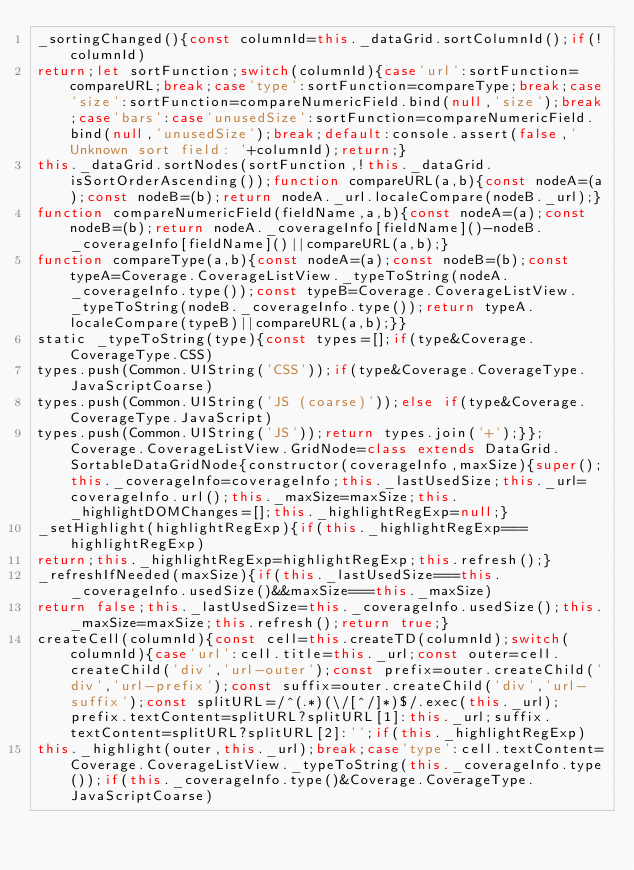<code> <loc_0><loc_0><loc_500><loc_500><_JavaScript_>_sortingChanged(){const columnId=this._dataGrid.sortColumnId();if(!columnId)
return;let sortFunction;switch(columnId){case'url':sortFunction=compareURL;break;case'type':sortFunction=compareType;break;case'size':sortFunction=compareNumericField.bind(null,'size');break;case'bars':case'unusedSize':sortFunction=compareNumericField.bind(null,'unusedSize');break;default:console.assert(false,'Unknown sort field: '+columnId);return;}
this._dataGrid.sortNodes(sortFunction,!this._dataGrid.isSortOrderAscending());function compareURL(a,b){const nodeA=(a);const nodeB=(b);return nodeA._url.localeCompare(nodeB._url);}
function compareNumericField(fieldName,a,b){const nodeA=(a);const nodeB=(b);return nodeA._coverageInfo[fieldName]()-nodeB._coverageInfo[fieldName]()||compareURL(a,b);}
function compareType(a,b){const nodeA=(a);const nodeB=(b);const typeA=Coverage.CoverageListView._typeToString(nodeA._coverageInfo.type());const typeB=Coverage.CoverageListView._typeToString(nodeB._coverageInfo.type());return typeA.localeCompare(typeB)||compareURL(a,b);}}
static _typeToString(type){const types=[];if(type&Coverage.CoverageType.CSS)
types.push(Common.UIString('CSS'));if(type&Coverage.CoverageType.JavaScriptCoarse)
types.push(Common.UIString('JS (coarse)'));else if(type&Coverage.CoverageType.JavaScript)
types.push(Common.UIString('JS'));return types.join('+');}};Coverage.CoverageListView.GridNode=class extends DataGrid.SortableDataGridNode{constructor(coverageInfo,maxSize){super();this._coverageInfo=coverageInfo;this._lastUsedSize;this._url=coverageInfo.url();this._maxSize=maxSize;this._highlightDOMChanges=[];this._highlightRegExp=null;}
_setHighlight(highlightRegExp){if(this._highlightRegExp===highlightRegExp)
return;this._highlightRegExp=highlightRegExp;this.refresh();}
_refreshIfNeeded(maxSize){if(this._lastUsedSize===this._coverageInfo.usedSize()&&maxSize===this._maxSize)
return false;this._lastUsedSize=this._coverageInfo.usedSize();this._maxSize=maxSize;this.refresh();return true;}
createCell(columnId){const cell=this.createTD(columnId);switch(columnId){case'url':cell.title=this._url;const outer=cell.createChild('div','url-outer');const prefix=outer.createChild('div','url-prefix');const suffix=outer.createChild('div','url-suffix');const splitURL=/^(.*)(\/[^/]*)$/.exec(this._url);prefix.textContent=splitURL?splitURL[1]:this._url;suffix.textContent=splitURL?splitURL[2]:'';if(this._highlightRegExp)
this._highlight(outer,this._url);break;case'type':cell.textContent=Coverage.CoverageListView._typeToString(this._coverageInfo.type());if(this._coverageInfo.type()&Coverage.CoverageType.JavaScriptCoarse)</code> 